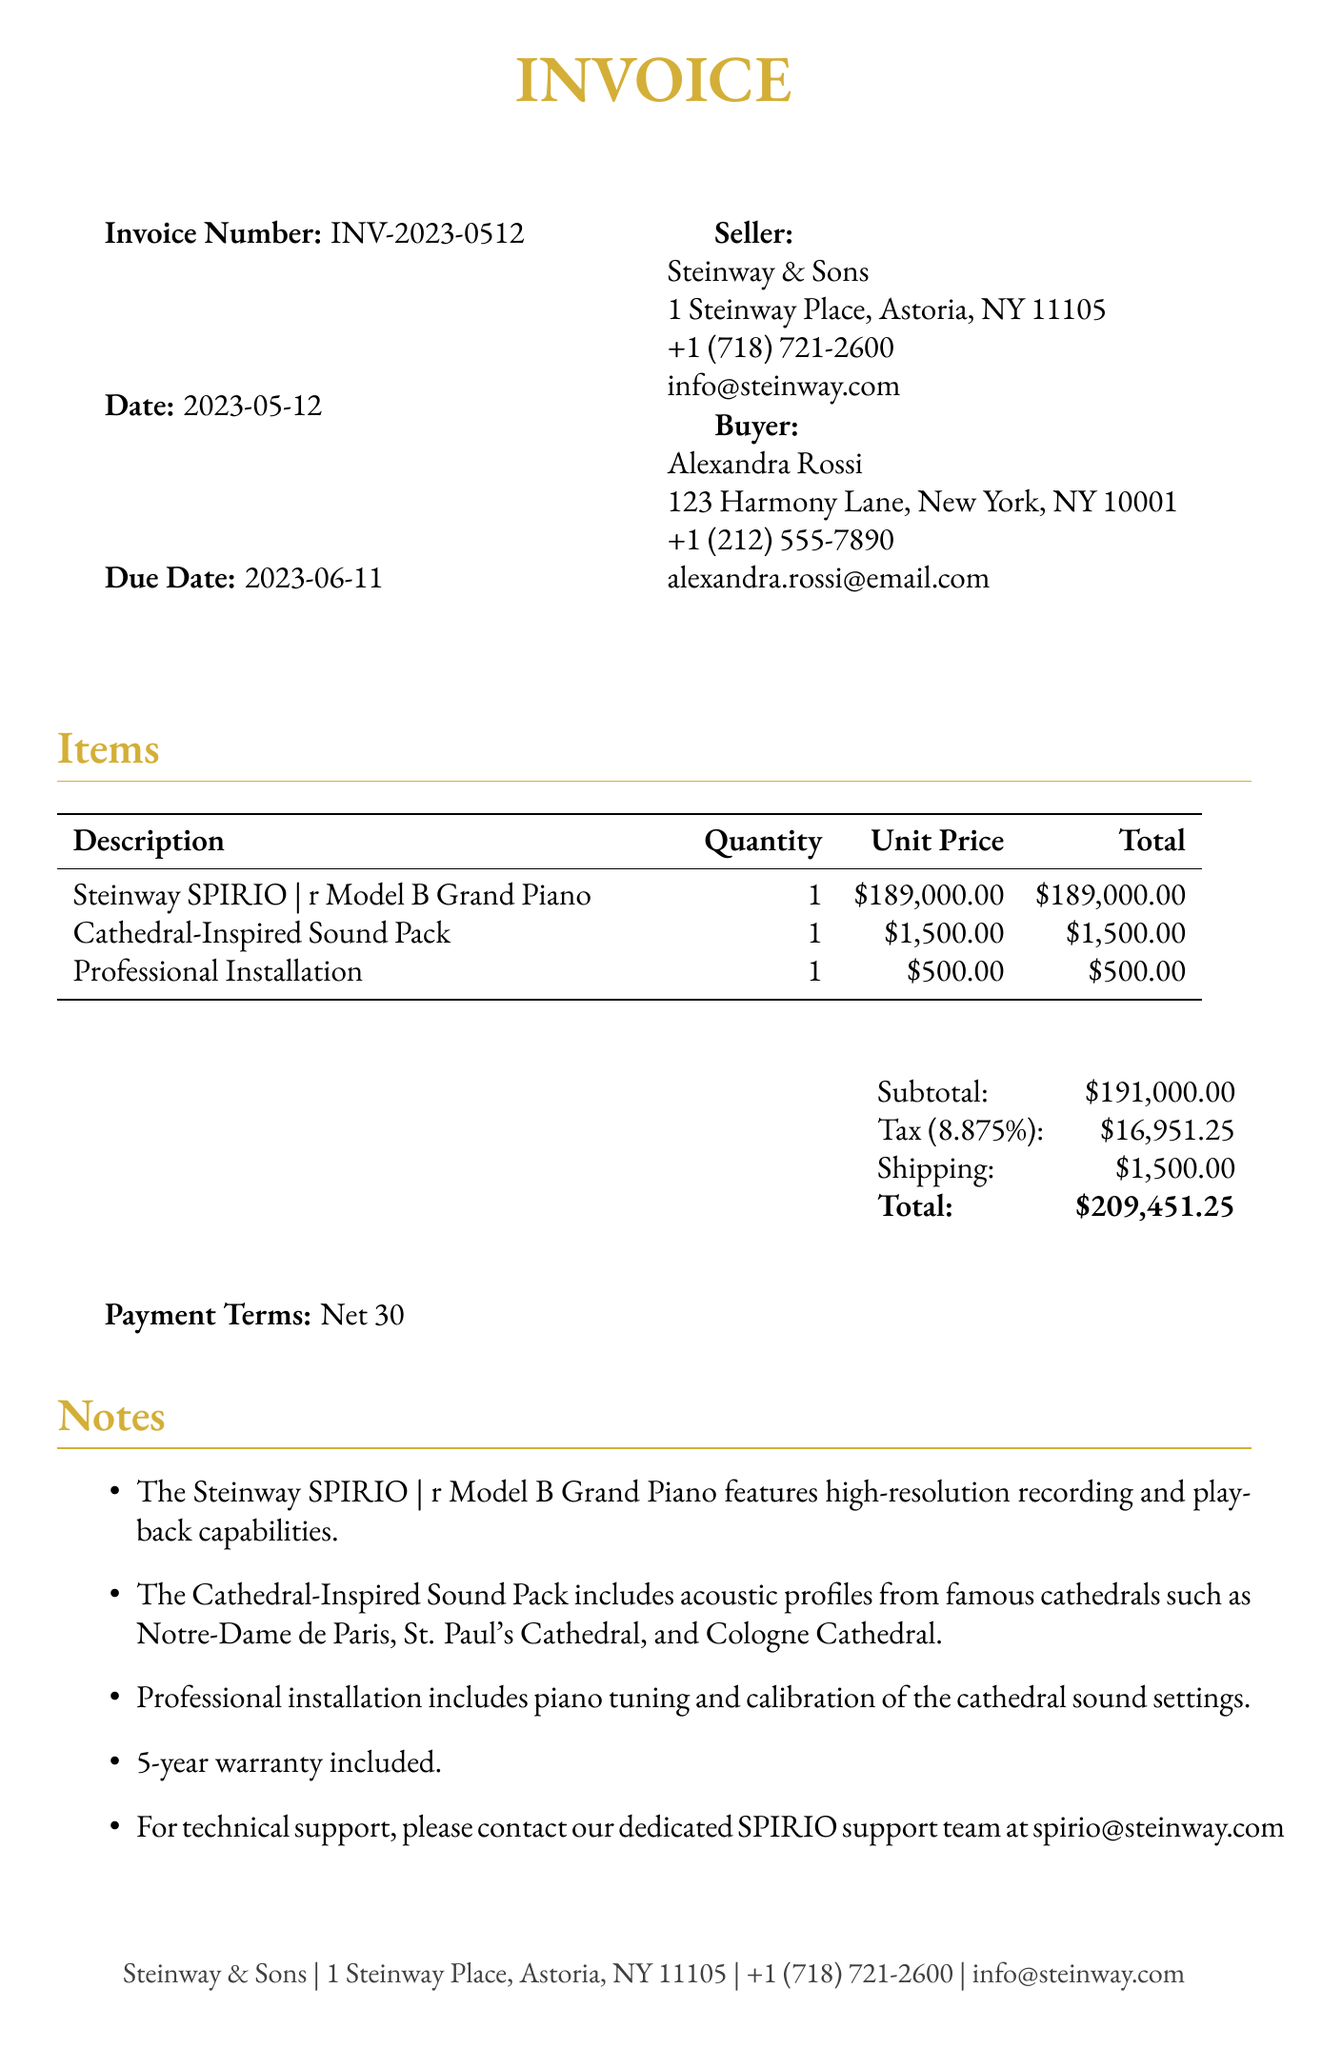What is the invoice number? The invoice number is a unique identifier for this transaction and can be found at the top of the document.
Answer: INV-2023-0512 Who is the seller? The seller's name and address are provided in the document under the seller section.
Answer: Steinway & Sons What is the total amount due? The total amount due is calculated as the sum of the subtotal, tax, and shipping costs.
Answer: $209,451.25 What is the due date for payment? The due date indicates when the payment must be made, specified in the document.
Answer: 2023-06-11 What is included in the Cathedral-Inspired Sound Pack? The note mentions the contents of the sound pack and highlights famous cathedral profiles.
Answer: Notre-Dame de Paris, St. Paul's Cathedral, and Cologne Cathedral How many items are listed in the invoice? The number of items can be counted from the items section of the document.
Answer: 3 What are the payment terms? Payment terms clarify the timeline for payment completion and can be found towards the end of the document.
Answer: Net 30 How long is the warranty included? The warranty duration is mentioned as part of the notes section of the invoice.
Answer: 5 years What additional feature assists with controlling the SPIRIO system? One of the additional features specifically supports this function.
Answer: Built-in iPad Pro 